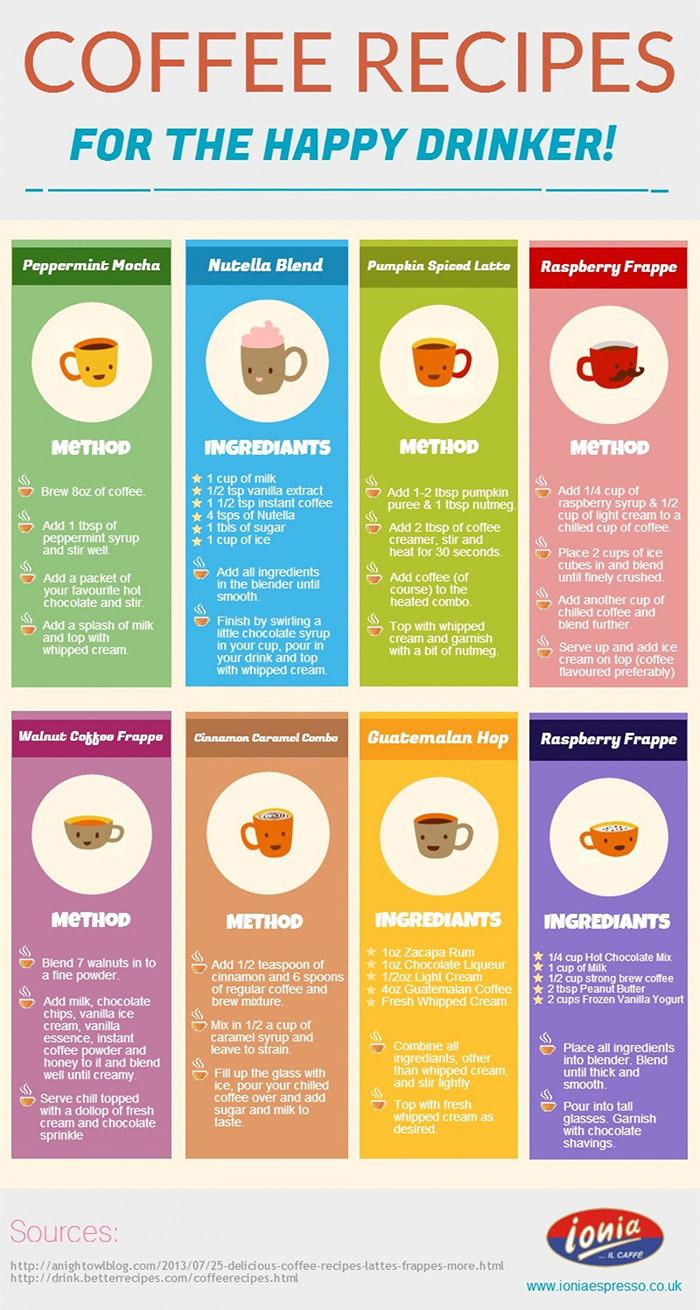Give some essential details in this illustration. There are two sources listed. 